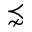<formula> <loc_0><loc_0><loc_500><loc_500>\precnsim</formula> 